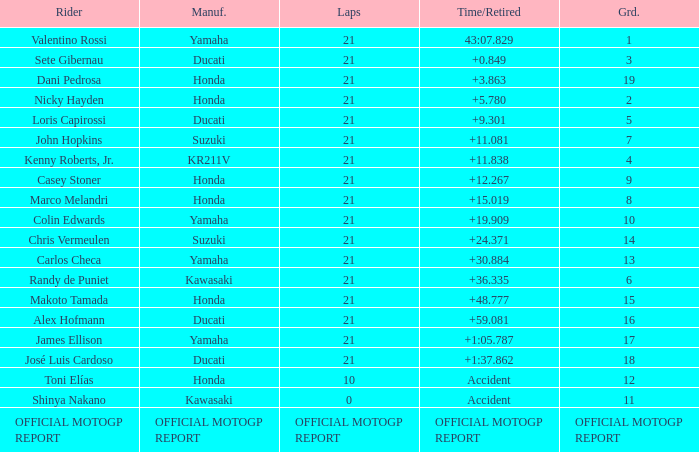When rider John Hopkins had 21 laps, what was the grid? 7.0. 